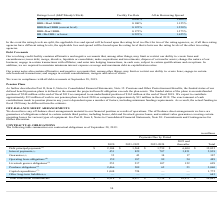According to Tyson Foods's financial document, What happens when all three rating agencies have different rating levels? the applicable fees and spread will be based upon the rating level that is between the rating levels of the other two rating agencies.. The document states: "hree rating agencies have different rating levels, the applicable fees and spread will be based upon the rating level that is between the rating level..." Also, What percentage of the loan is the company currently paying for the unused portion of the facility? According to the financial document, 0.125%. The relevant text states: "BBB/Baa2/BBB (current level) 0.125% 1.250%..." Also, What are the firm's current credit rating by the three rating agencies? The document contains multiple relevant values: Standard & Poor's Rating Services', a Standard & Poor's Financial Services LLC business ("S&P"), corporate credit rating is "BBB.", Moody’s Investor Service, Inc.'s ("Moody's") applicable rating is "Baa2.", Fitch Ratings', a wholly owned subsidiary of Fimlac, S.A. ("Fitch"), applicable rating is "BBB.". Also, can you calculate: What is the difference in Facility Fee Rate between Tyson Foods and a company with a credit rating of A-/A3/A- or above? Based on the calculation: 0.125% - 0.09%, the result is 0.04 (percentage). This is based on the information: "A-/A3/A- or above 0.090% 1.000% BBB/Baa2/BBB (current level) 0.125% 1.250%..." The key data points involved are: 0.09, 0.125. Also, can you calculate: What is the difference between the All-in Borrowing Spread and the Facility Fee Rate for Tyson Foods currently? Based on the calculation: 1.250% - 0.125%, the result is 1.13 (percentage). This is based on the information: "BBB/Baa2/BBB (current level) 0.125% 1.250% BBB/Baa2/BBB (current level) 0.125% 1.250%..." The key data points involved are: 0.125, 1.250. Also, can you calculate: Suppose the approved loan amount for Tyson Foods is $12 million. What is the Facility Fee Rate payable? Based on the calculation: 0.125% * 12, the result is 0.01 (in millions). This is based on the information: "BBB/Baa2/BBB (current level) 0.125% 1.250% BBB/Baa2/BBB (current level) 0.125% 1.250%..." The key data points involved are: 0.125, 12. 